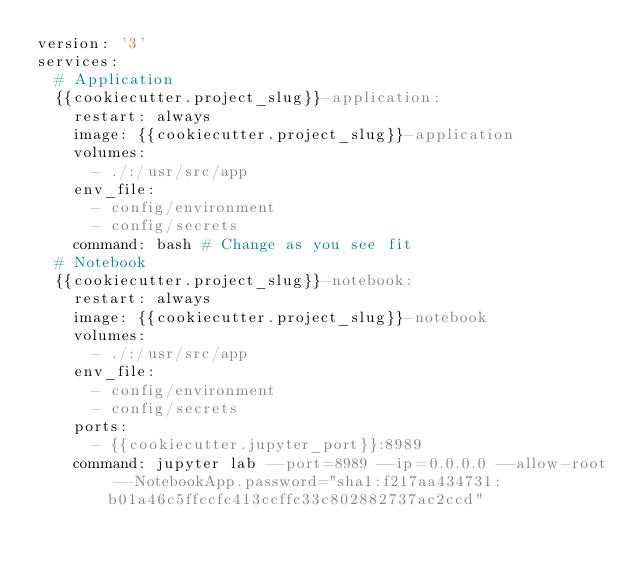<code> <loc_0><loc_0><loc_500><loc_500><_YAML_>version: '3'
services:
  # Application
  {{cookiecutter.project_slug}}-application:
    restart: always
    image: {{cookiecutter.project_slug}}-application
    volumes:
      - ./:/usr/src/app
    env_file:
      - config/environment
      - config/secrets
    command: bash # Change as you see fit
  # Notebook
  {{cookiecutter.project_slug}}-notebook:
    restart: always
    image: {{cookiecutter.project_slug}}-notebook
    volumes:
      - ./:/usr/src/app
    env_file:
      - config/environment
      - config/secrets
    ports:
      - {{cookiecutter.jupyter_port}}:8989
    command: jupyter lab --port=8989 --ip=0.0.0.0 --allow-root --NotebookApp.password="sha1:f217aa434731:b01a46c5ffccfc413ccffc33c802882737ac2ccd"</code> 